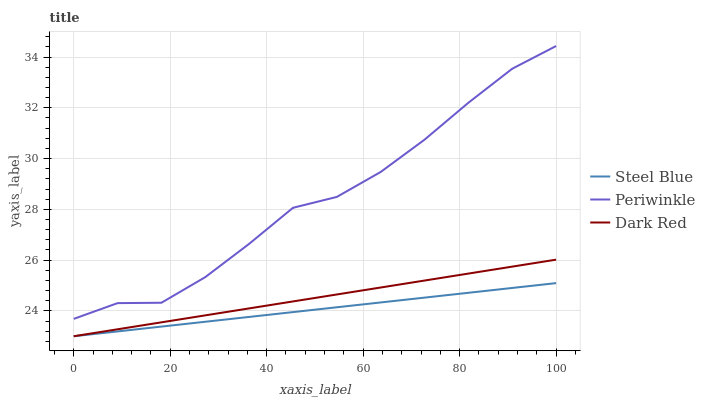Does Steel Blue have the minimum area under the curve?
Answer yes or no. Yes. Does Periwinkle have the maximum area under the curve?
Answer yes or no. Yes. Does Periwinkle have the minimum area under the curve?
Answer yes or no. No. Does Steel Blue have the maximum area under the curve?
Answer yes or no. No. Is Steel Blue the smoothest?
Answer yes or no. Yes. Is Periwinkle the roughest?
Answer yes or no. Yes. Is Periwinkle the smoothest?
Answer yes or no. No. Is Steel Blue the roughest?
Answer yes or no. No. Does Periwinkle have the lowest value?
Answer yes or no. No. Does Periwinkle have the highest value?
Answer yes or no. Yes. Does Steel Blue have the highest value?
Answer yes or no. No. Is Steel Blue less than Periwinkle?
Answer yes or no. Yes. Is Periwinkle greater than Dark Red?
Answer yes or no. Yes. Does Dark Red intersect Steel Blue?
Answer yes or no. Yes. Is Dark Red less than Steel Blue?
Answer yes or no. No. Is Dark Red greater than Steel Blue?
Answer yes or no. No. Does Steel Blue intersect Periwinkle?
Answer yes or no. No. 